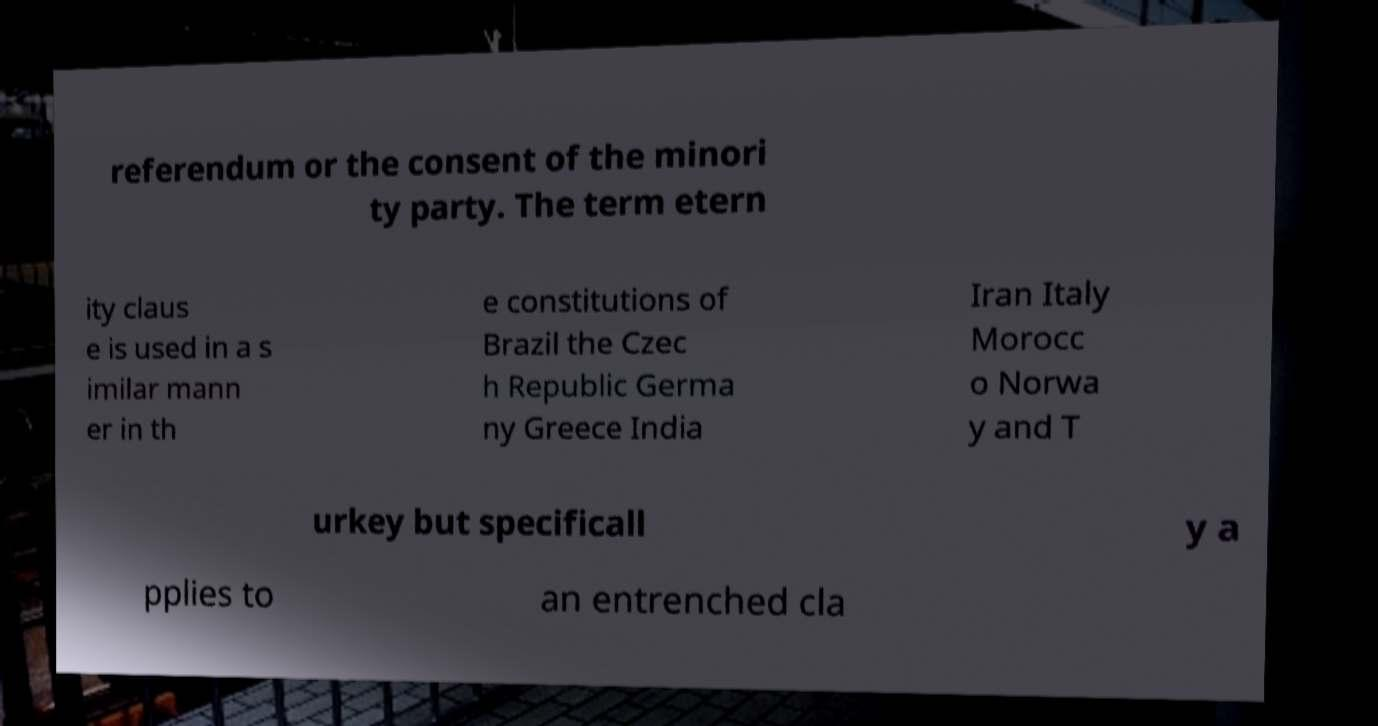Can you accurately transcribe the text from the provided image for me? referendum or the consent of the minori ty party. The term etern ity claus e is used in a s imilar mann er in th e constitutions of Brazil the Czec h Republic Germa ny Greece India Iran Italy Morocc o Norwa y and T urkey but specificall y a pplies to an entrenched cla 